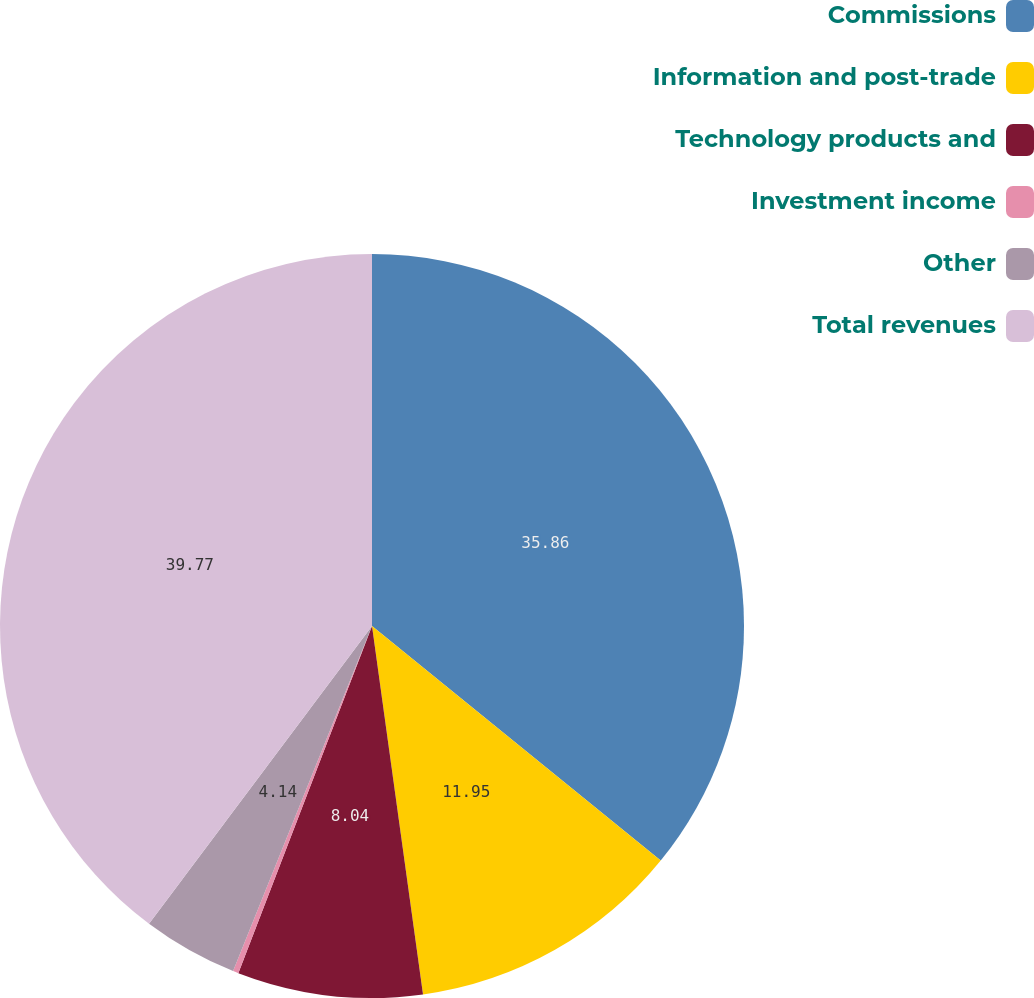<chart> <loc_0><loc_0><loc_500><loc_500><pie_chart><fcel>Commissions<fcel>Information and post-trade<fcel>Technology products and<fcel>Investment income<fcel>Other<fcel>Total revenues<nl><fcel>35.86%<fcel>11.95%<fcel>8.04%<fcel>0.24%<fcel>4.14%<fcel>39.77%<nl></chart> 